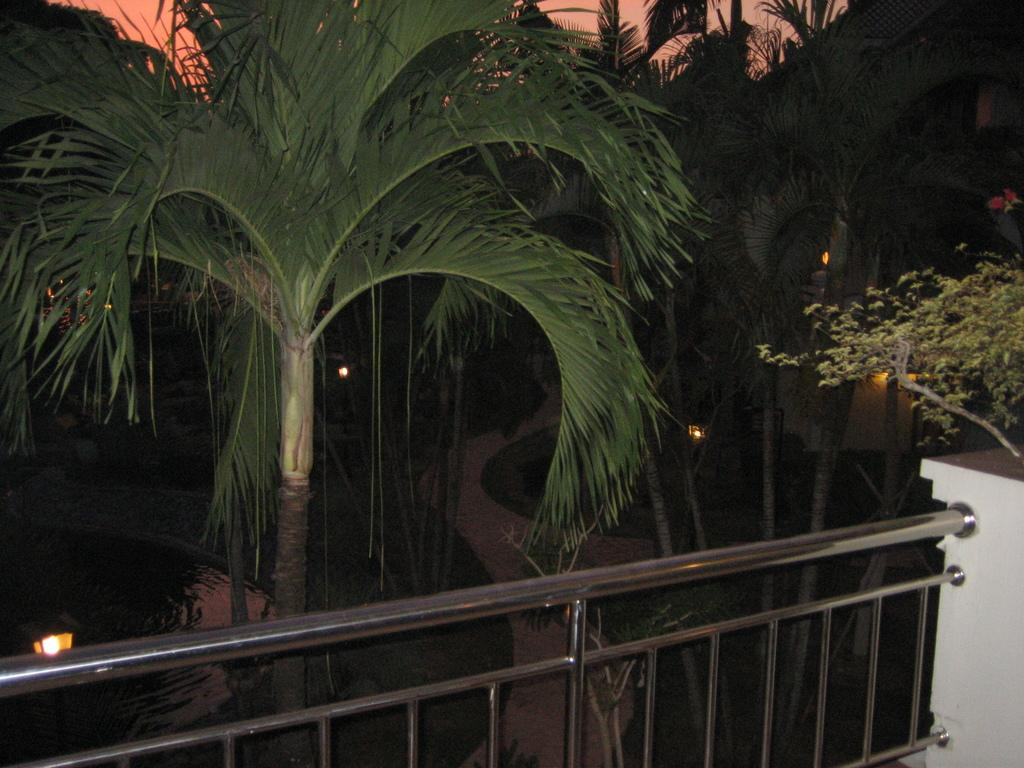What type of barrier can be seen in the image? There is a fence in the image. What other structure is present in the image? There is a wall in the image. What type of vegetation is visible in the image? There are trees in the image. What type of ground cover is present in the image? There is grass in the image. What part of the natural environment is visible in the image? The ground and the sky are visible in the image. What time of day is depicted in the image? The time of day is not visible in the image, as there are no clocks or other time indicators present. Can you see a kitten playing with the trees in the image? There is no kitten present in the image; it only features a fence, a wall, trees, grass, the ground, and the sky. 